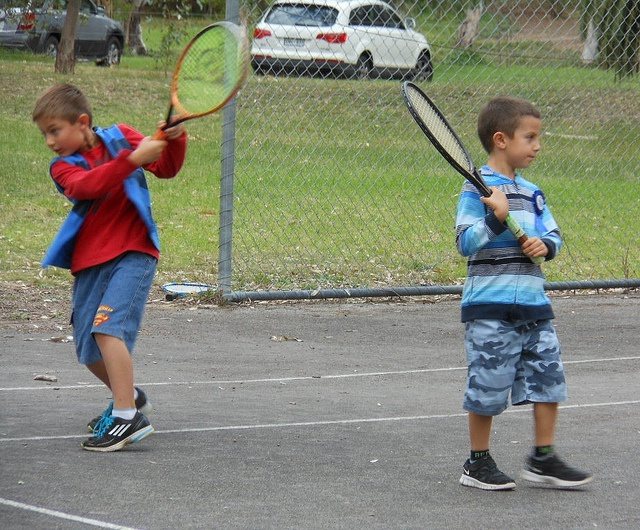Describe the objects in this image and their specific colors. I can see people in darkgreen, gray, black, and darkgray tones, people in darkgreen, maroon, brown, gray, and black tones, car in darkgreen, lightgray, darkgray, black, and gray tones, car in black, gray, darkgreen, and darkgray tones, and tennis racket in darkgreen, olive, darkgray, and lightgreen tones in this image. 